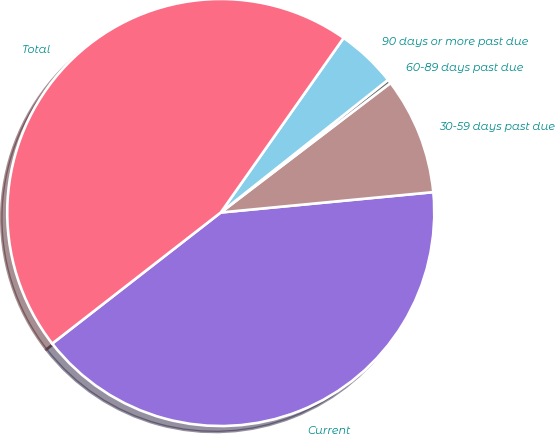Convert chart. <chart><loc_0><loc_0><loc_500><loc_500><pie_chart><fcel>Current<fcel>30-59 days past due<fcel>60-89 days past due<fcel>90 days or more past due<fcel>Total<nl><fcel>41.0%<fcel>8.85%<fcel>0.3%<fcel>4.57%<fcel>45.28%<nl></chart> 